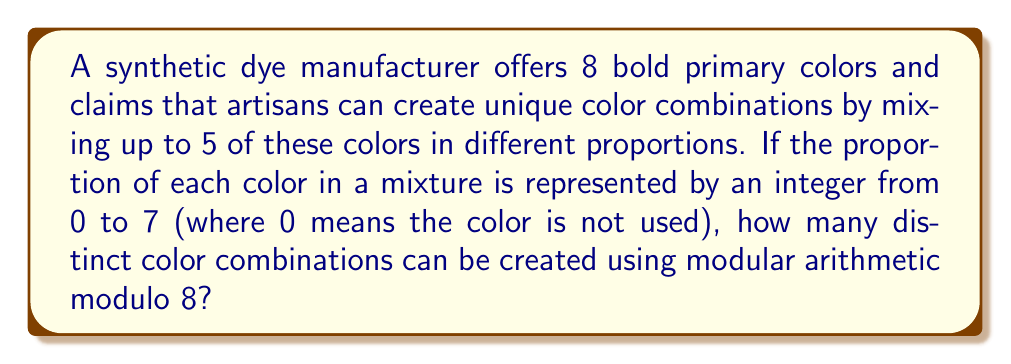Solve this math problem. Let's approach this step-by-step:

1) We have 8 primary colors, and each color can have 8 different proportions (0 to 7).

2) This scenario can be represented using modular arithmetic modulo 8, where each color's proportion is an element of $\mathbb{Z}_8$.

3) We need to calculate the number of ways to choose up to 5 colors from 8 colors, with repetition allowed (since a color can be used in different proportions).

4) This is equivalent to finding the number of 8-tuples $(a_1, a_2, ..., a_8)$ where:
   - Each $a_i \in \mathbb{Z}_8$
   - At most 5 of the $a_i$ are non-zero

5) We can use the principle of inclusion-exclusion:

   $$ \text{Total} = \binom{8}{0}8^0 + \binom{8}{1}8^1 + \binom{8}{2}8^2 + \binom{8}{3}8^3 + \binom{8}{4}8^4 + \binom{8}{5}8^5 $$

6) Let's calculate each term:
   $\binom{8}{0}8^0 = 1$
   $\binom{8}{1}8^1 = 8 \cdot 8 = 64$
   $\binom{8}{2}8^2 = 28 \cdot 64 = 1,792$
   $\binom{8}{3}8^3 = 56 \cdot 512 = 28,672$
   $\binom{8}{4}8^4 = 70 \cdot 4,096 = 286,720$
   $\binom{8}{5}8^5 = 56 \cdot 32,768 = 1,835,008$

7) Sum up all these terms:

   $$ 1 + 64 + 1,792 + 28,672 + 286,720 + 1,835,008 = 2,152,257 $$

Therefore, there are 2,152,257 distinct color combinations possible.
Answer: 2,152,257 